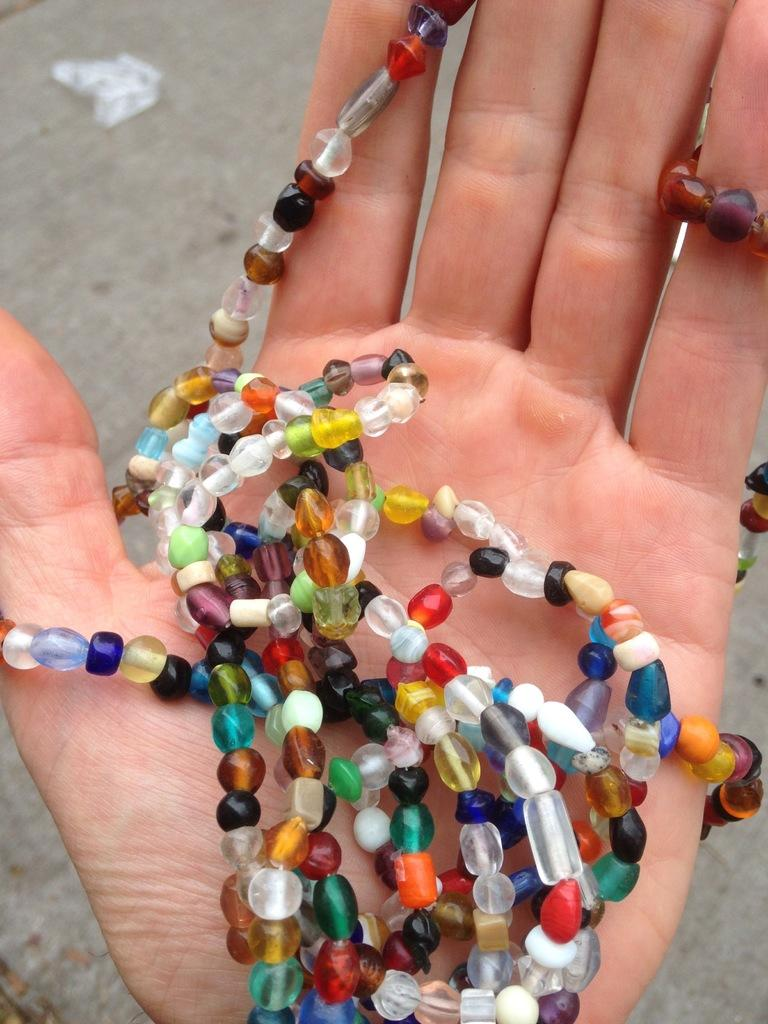What is the main subject of the image? There is a person in the image. What is the person holding in their hand? The person is holding a chain made up of beads in their hand. What color is the background of the hand? The background of the hand is blue. What type of cheese is visible on the person's finger in the image? There is no cheese visible on the person's finger in the image. What is the weather like in the image? The provided facts do not mention the weather, so we cannot determine the weather from the image. 